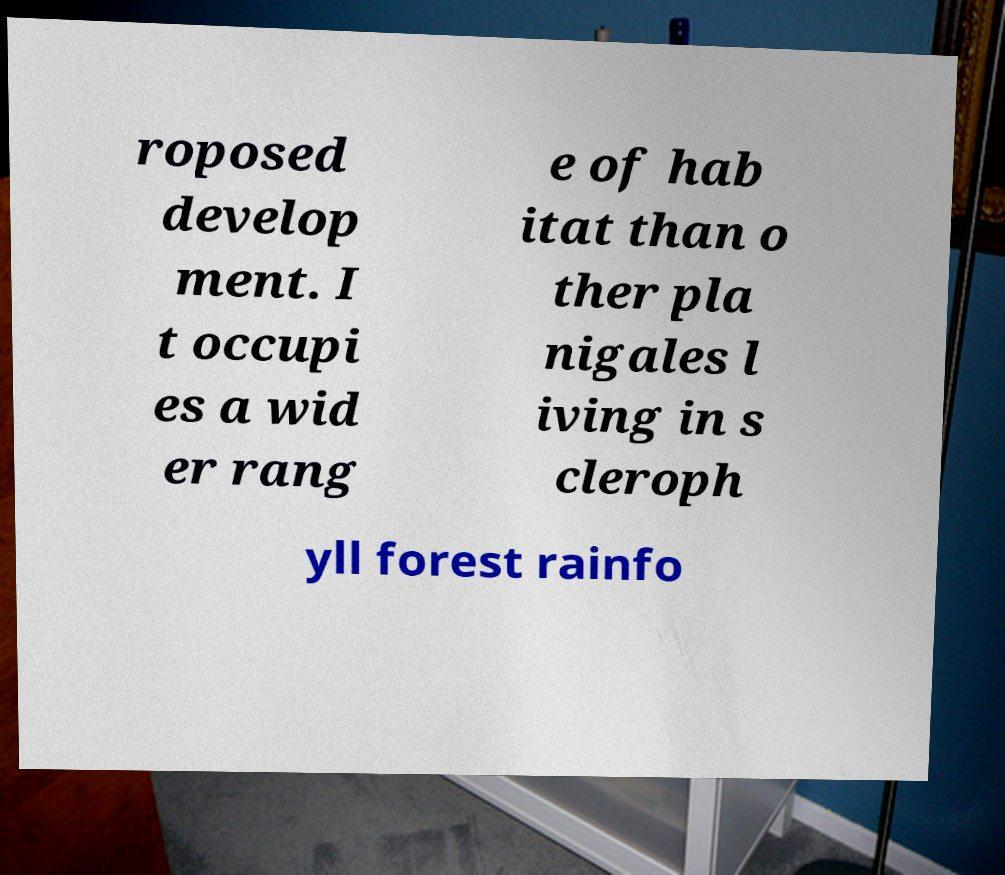Can you read and provide the text displayed in the image?This photo seems to have some interesting text. Can you extract and type it out for me? roposed develop ment. I t occupi es a wid er rang e of hab itat than o ther pla nigales l iving in s cleroph yll forest rainfo 